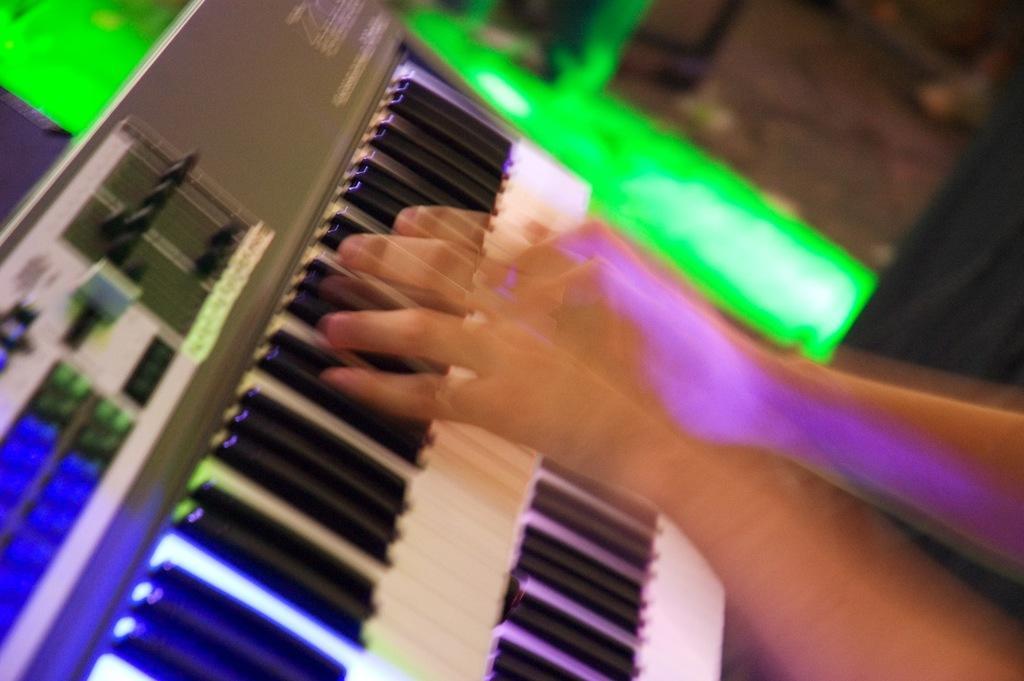How would you summarize this image in a sentence or two? This looks like an edited image. I can see a person's hands playing a piano. This is a keyboard. The background looks blurry. 